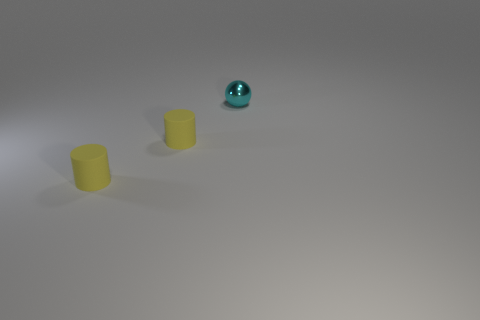What number of other cyan spheres are made of the same material as the ball?
Your response must be concise. 0. How many rubber things are cylinders or spheres?
Your response must be concise. 2. Is there any other thing that is the same color as the shiny sphere?
Provide a short and direct response. No. How many other objects are the same material as the tiny cyan sphere?
Provide a succinct answer. 0. Is there another cyan object that has the same shape as the small metallic thing?
Offer a very short reply. No. How many things are either yellow cylinders or things that are to the left of the tiny cyan metal object?
Ensure brevity in your answer.  2. Is there a cyan cube of the same size as the cyan shiny object?
Offer a very short reply. No. What material is the small sphere?
Offer a terse response. Metal. There is a cyan object; what number of matte objects are to the left of it?
Provide a succinct answer. 2. What number of small objects are the same color as the metallic ball?
Provide a short and direct response. 0. 